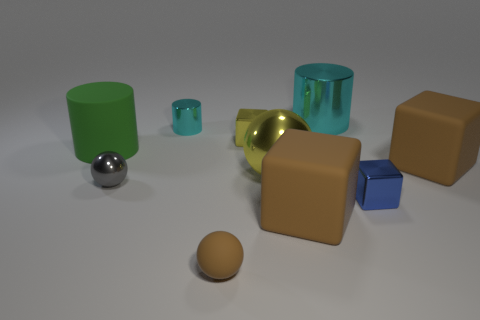How many objects are either large yellow balls or cyan things on the left side of the big yellow thing?
Offer a terse response. 2. Is there anything else that is the same material as the big cyan object?
Provide a short and direct response. Yes. There is a shiny object that is the same color as the small metal cylinder; what shape is it?
Give a very brief answer. Cylinder. What is the material of the green thing?
Give a very brief answer. Rubber. Does the small blue cube have the same material as the tiny cyan cylinder?
Offer a very short reply. Yes. What number of shiny objects are small yellow blocks or brown objects?
Provide a succinct answer. 1. What is the shape of the brown object that is behind the tiny gray ball?
Your answer should be compact. Cube. There is a blue cube that is the same material as the tiny gray object; what is its size?
Your answer should be very brief. Small. The thing that is in front of the large green rubber cylinder and on the left side of the tiny cyan metal cylinder has what shape?
Offer a very short reply. Sphere. Is the color of the metallic cylinder to the left of the rubber sphere the same as the small matte thing?
Offer a terse response. No. 